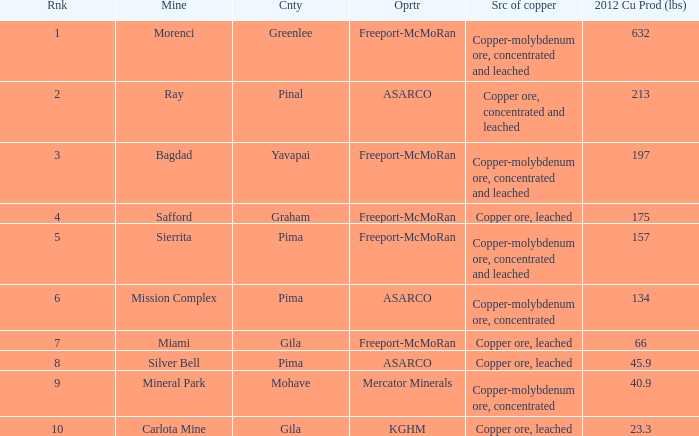Help me parse the entirety of this table. {'header': ['Rnk', 'Mine', 'Cnty', 'Oprtr', 'Src of copper', '2012 Cu Prod (lbs)'], 'rows': [['1', 'Morenci', 'Greenlee', 'Freeport-McMoRan', 'Copper-molybdenum ore, concentrated and leached', '632'], ['2', 'Ray', 'Pinal', 'ASARCO', 'Copper ore, concentrated and leached', '213'], ['3', 'Bagdad', 'Yavapai', 'Freeport-McMoRan', 'Copper-molybdenum ore, concentrated and leached', '197'], ['4', 'Safford', 'Graham', 'Freeport-McMoRan', 'Copper ore, leached', '175'], ['5', 'Sierrita', 'Pima', 'Freeport-McMoRan', 'Copper-molybdenum ore, concentrated and leached', '157'], ['6', 'Mission Complex', 'Pima', 'ASARCO', 'Copper-molybdenum ore, concentrated', '134'], ['7', 'Miami', 'Gila', 'Freeport-McMoRan', 'Copper ore, leached', '66'], ['8', 'Silver Bell', 'Pima', 'ASARCO', 'Copper ore, leached', '45.9'], ['9', 'Mineral Park', 'Mohave', 'Mercator Minerals', 'Copper-molybdenum ore, concentrated', '40.9'], ['10', 'Carlota Mine', 'Gila', 'KGHM', 'Copper ore, leached', '23.3']]} What's the lowest ranking source of copper, copper ore, concentrated and leached? 2.0. 